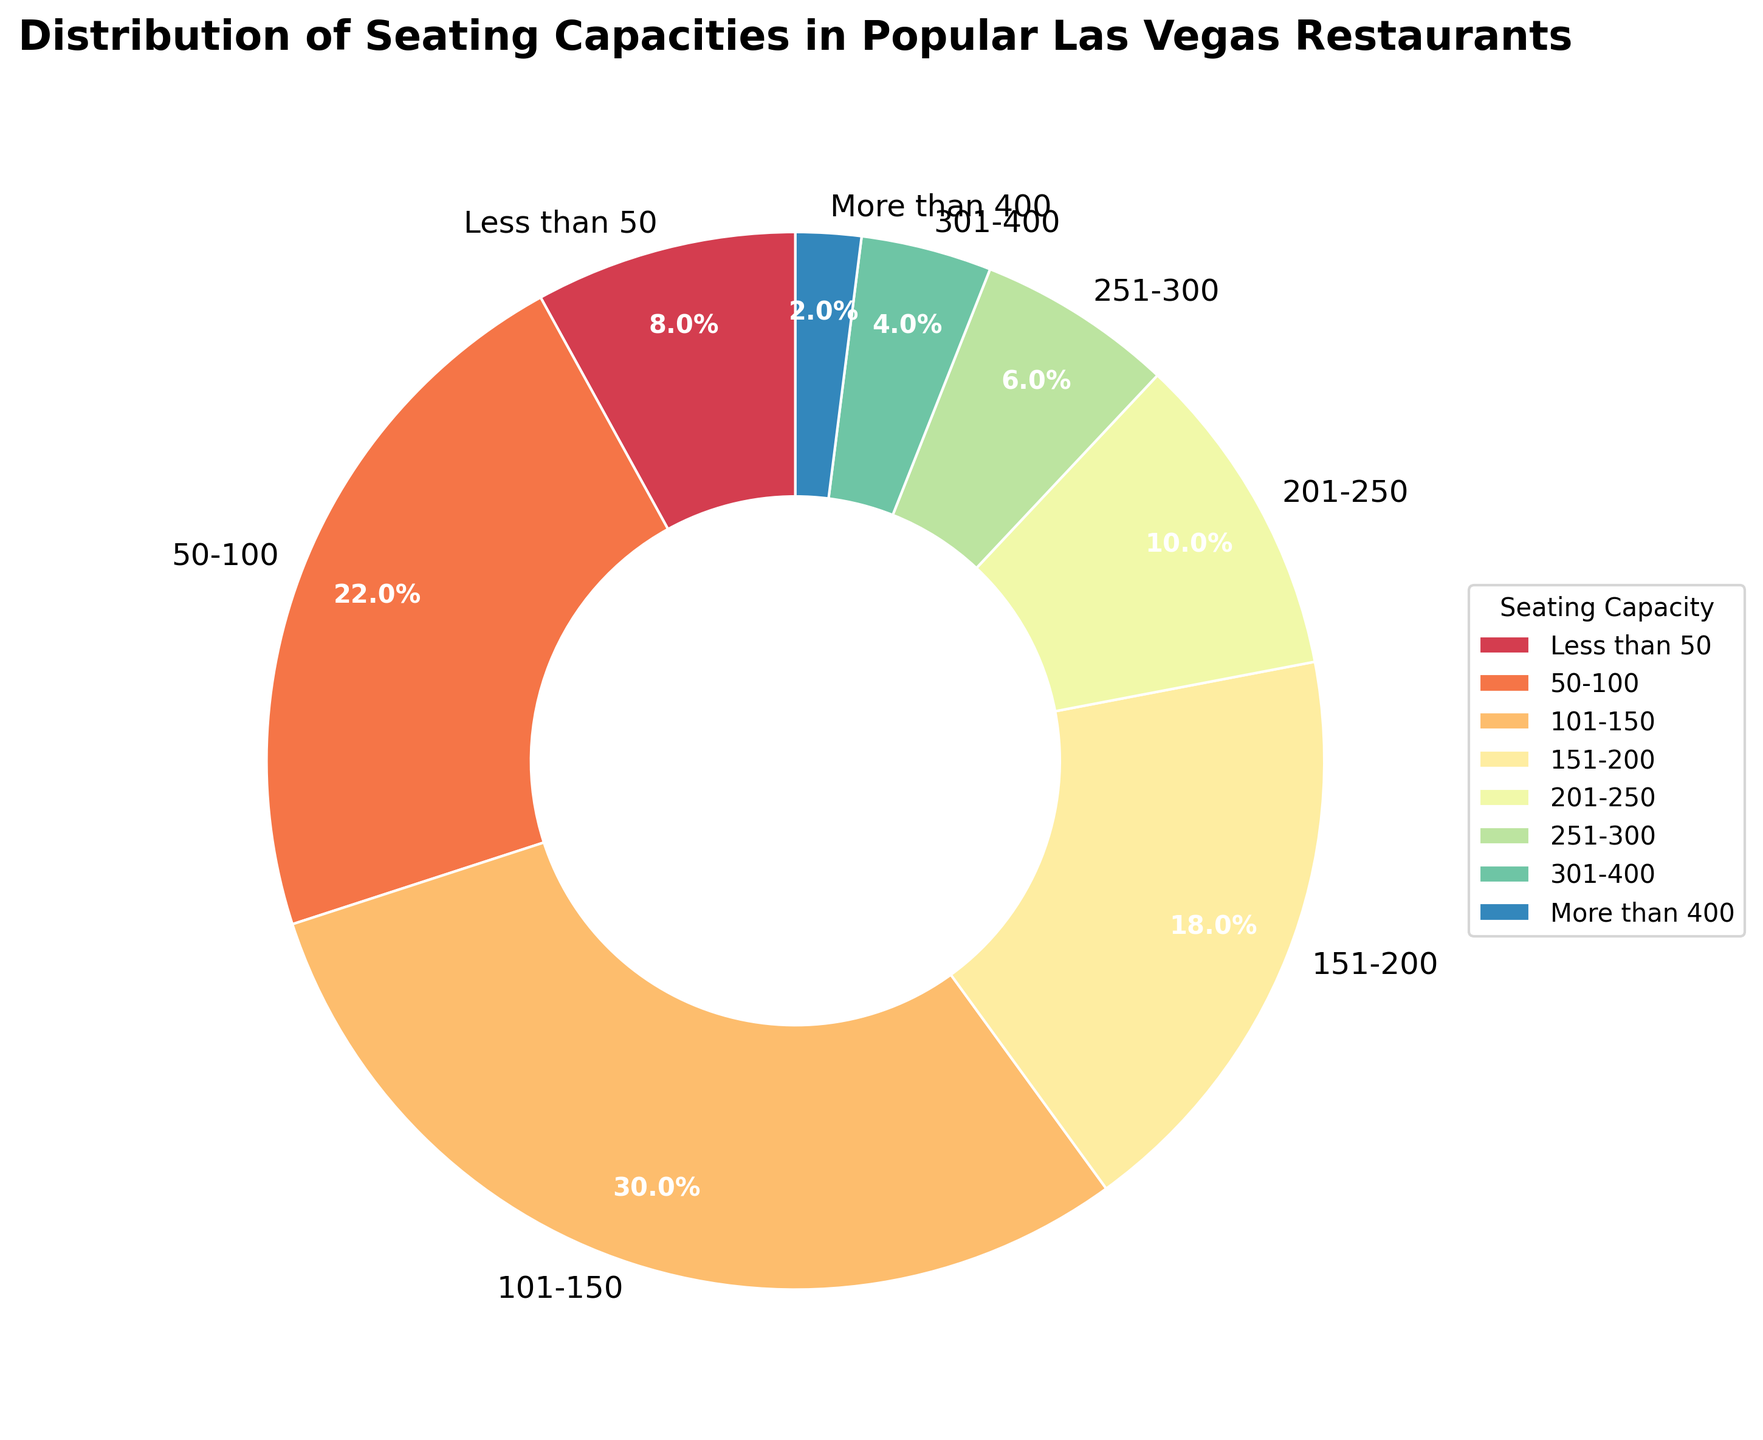Which seating capacity range has the largest proportion? The largest proportion is visually the biggest segment in the pie chart. The segment labeled "101-150" is the largest.
Answer: 101-150 Which seating capacity range has the smallest proportion? The smallest proportion is visually the smallest segment in the pie chart. The segment labeled "More than 400" is the smallest.
Answer: More than 400 What percentage of restaurants have seating capacities between 50 and 150? Adding the percentages of the "50-100" and "101-150" segments: 22% + 30% = 52%.
Answer: 52% Are there more restaurants with seating capacities less than 200 or more than 200? Adding the percentages for capacities less than 200 (Less than 50, 50-100, 101-150, 151-200): 8% + 22% + 30% + 18% = 78%. Adding the percentages for capacities more than 200 (201-250, 251-300, 301-400, More than 400): 10% + 6% + 4% + 2% = 22%. 78% > 22%.
Answer: Less than 200 What is the combined percentage of restaurants with seating capacities between 151 and 400? Adding the percentages for the "151-200", "201-250", "251-300", and "301-400" segments: 18% + 10% + 6% + 4% = 38%.
Answer: 38% How does the proportion of restaurants with seating capacities 101-150 compare to those with 151-200? Comparing the "101-150" and "151-200" segments: 30% vs. 18%. 30% > 18%.
Answer: 101-150 has a larger proportion Which color is used for the segment representing the 101-150 seating capacity range? The segment for the "101-150" range is visually identified by its color, which is a shade from the Spectral colormap, appearing as a vibrant purple.
Answer: Purple 